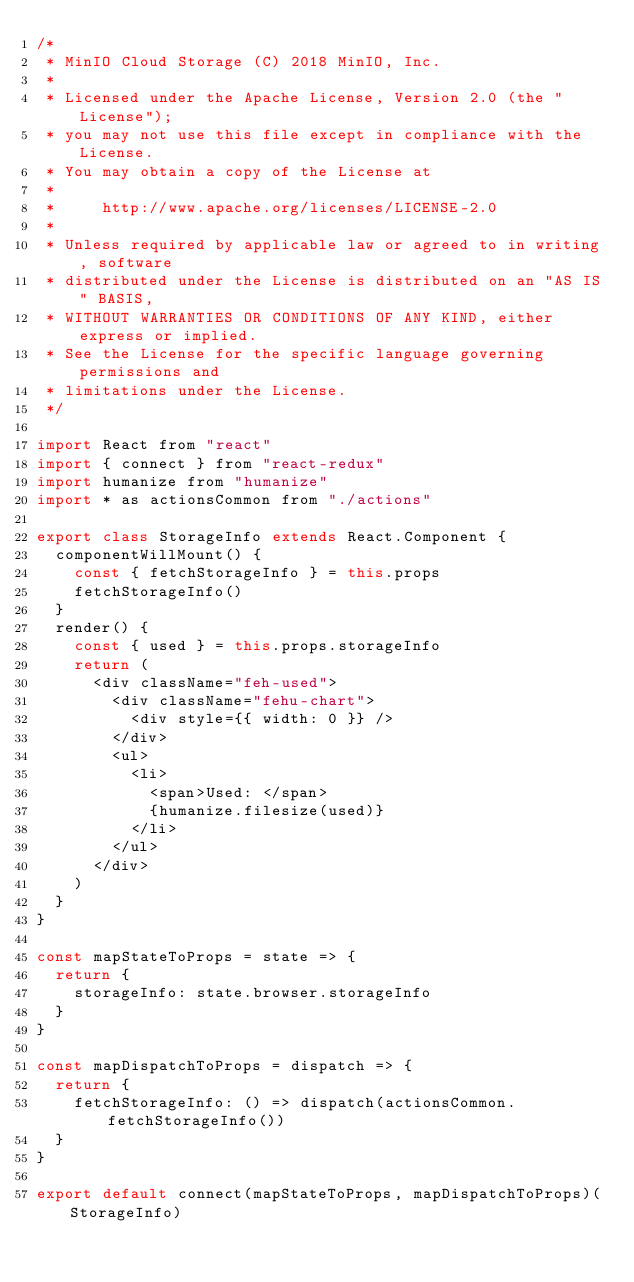Convert code to text. <code><loc_0><loc_0><loc_500><loc_500><_JavaScript_>/*
 * MinIO Cloud Storage (C) 2018 MinIO, Inc.
 *
 * Licensed under the Apache License, Version 2.0 (the "License");
 * you may not use this file except in compliance with the License.
 * You may obtain a copy of the License at
 *
 *     http://www.apache.org/licenses/LICENSE-2.0
 *
 * Unless required by applicable law or agreed to in writing, software
 * distributed under the License is distributed on an "AS IS" BASIS,
 * WITHOUT WARRANTIES OR CONDITIONS OF ANY KIND, either express or implied.
 * See the License for the specific language governing permissions and
 * limitations under the License.
 */

import React from "react"
import { connect } from "react-redux"
import humanize from "humanize"
import * as actionsCommon from "./actions"

export class StorageInfo extends React.Component {
  componentWillMount() {
    const { fetchStorageInfo } = this.props
    fetchStorageInfo()
  }
  render() {
    const { used } = this.props.storageInfo
    return (
      <div className="feh-used">
        <div className="fehu-chart">
          <div style={{ width: 0 }} />
        </div>
        <ul>
          <li>
            <span>Used: </span>
            {humanize.filesize(used)}
          </li>
        </ul>
      </div>
    )
  }
}

const mapStateToProps = state => {
  return {
    storageInfo: state.browser.storageInfo
  }
}

const mapDispatchToProps = dispatch => {
  return {
    fetchStorageInfo: () => dispatch(actionsCommon.fetchStorageInfo())
  }
}

export default connect(mapStateToProps, mapDispatchToProps)(StorageInfo)
</code> 